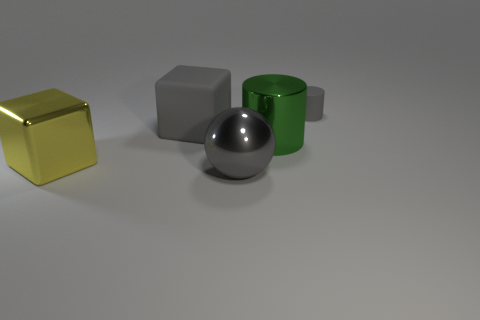Is the number of big matte objects that are behind the gray cylinder the same as the number of large gray metallic spheres? no 